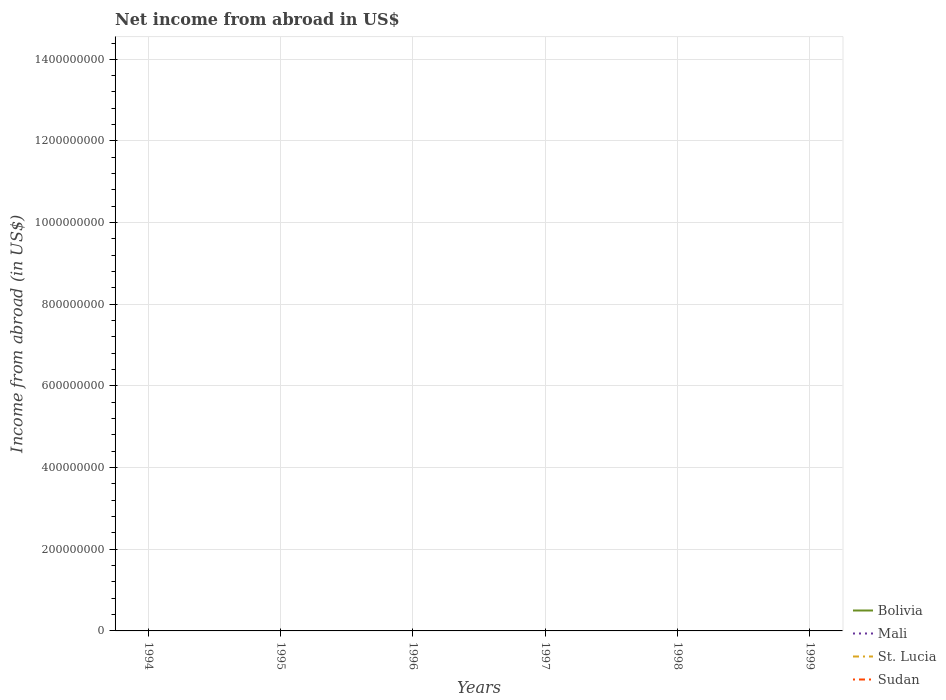How many different coloured lines are there?
Ensure brevity in your answer.  0. Is the number of lines equal to the number of legend labels?
Your answer should be compact. No. What is the difference between the highest and the lowest net income from abroad in St. Lucia?
Give a very brief answer. 0. How many lines are there?
Ensure brevity in your answer.  0. How many years are there in the graph?
Ensure brevity in your answer.  6. Are the values on the major ticks of Y-axis written in scientific E-notation?
Keep it short and to the point. No. Does the graph contain any zero values?
Offer a terse response. Yes. Does the graph contain grids?
Offer a very short reply. Yes. Where does the legend appear in the graph?
Ensure brevity in your answer.  Bottom right. How many legend labels are there?
Provide a succinct answer. 4. What is the title of the graph?
Make the answer very short. Net income from abroad in US$. What is the label or title of the X-axis?
Provide a succinct answer. Years. What is the label or title of the Y-axis?
Provide a succinct answer. Income from abroad (in US$). What is the Income from abroad (in US$) in Bolivia in 1994?
Ensure brevity in your answer.  0. What is the Income from abroad (in US$) of Mali in 1994?
Your answer should be compact. 0. What is the Income from abroad (in US$) in Sudan in 1994?
Make the answer very short. 0. What is the Income from abroad (in US$) in St. Lucia in 1995?
Make the answer very short. 0. What is the Income from abroad (in US$) of Sudan in 1995?
Your response must be concise. 0. What is the Income from abroad (in US$) of Mali in 1996?
Provide a succinct answer. 0. What is the Income from abroad (in US$) in Bolivia in 1997?
Offer a terse response. 0. What is the Income from abroad (in US$) of St. Lucia in 1997?
Ensure brevity in your answer.  0. What is the Income from abroad (in US$) in Sudan in 1997?
Provide a succinct answer. 0. What is the Income from abroad (in US$) of Bolivia in 1998?
Provide a short and direct response. 0. What is the Income from abroad (in US$) of Sudan in 1998?
Make the answer very short. 0. What is the Income from abroad (in US$) in Bolivia in 1999?
Ensure brevity in your answer.  0. What is the Income from abroad (in US$) of St. Lucia in 1999?
Make the answer very short. 0. What is the total Income from abroad (in US$) of Bolivia in the graph?
Your answer should be compact. 0. What is the total Income from abroad (in US$) of Mali in the graph?
Make the answer very short. 0. What is the total Income from abroad (in US$) in Sudan in the graph?
Your response must be concise. 0. What is the average Income from abroad (in US$) of Mali per year?
Give a very brief answer. 0. 